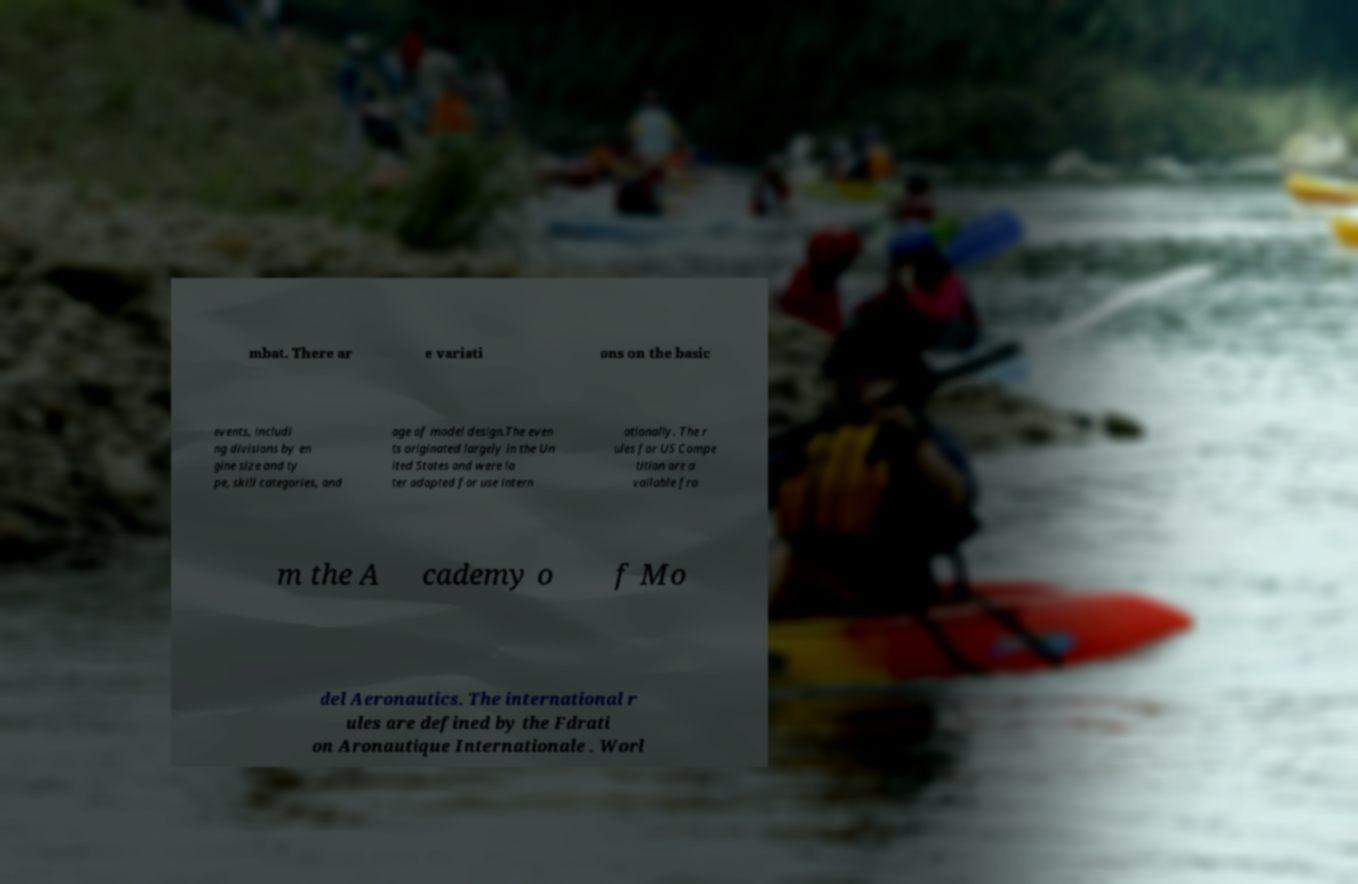What messages or text are displayed in this image? I need them in a readable, typed format. mbat. There ar e variati ons on the basic events, includi ng divisions by en gine size and ty pe, skill categories, and age of model design.The even ts originated largely in the Un ited States and were la ter adapted for use intern ationally. The r ules for US Compe tition are a vailable fro m the A cademy o f Mo del Aeronautics. The international r ules are defined by the Fdrati on Aronautique Internationale . Worl 